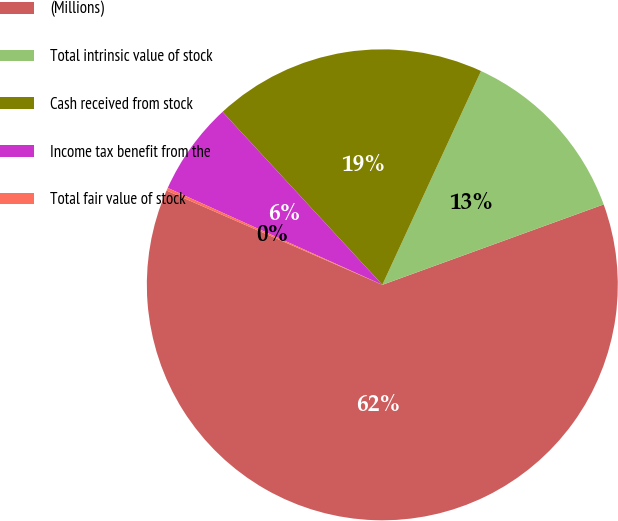Convert chart. <chart><loc_0><loc_0><loc_500><loc_500><pie_chart><fcel>(Millions)<fcel>Total intrinsic value of stock<fcel>Cash received from stock<fcel>Income tax benefit from the<fcel>Total fair value of stock<nl><fcel>62.11%<fcel>12.57%<fcel>18.76%<fcel>6.38%<fcel>0.19%<nl></chart> 